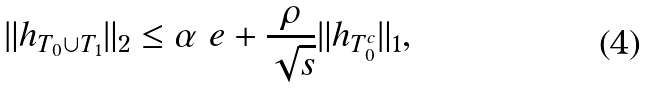Convert formula to latex. <formula><loc_0><loc_0><loc_500><loc_500>\| h _ { T _ { 0 } \cup T _ { 1 } } \| _ { 2 } \leq \alpha \ e + \frac { \rho } { \sqrt { s } } \| h _ { T _ { 0 } ^ { c } } \| _ { 1 } ,</formula> 